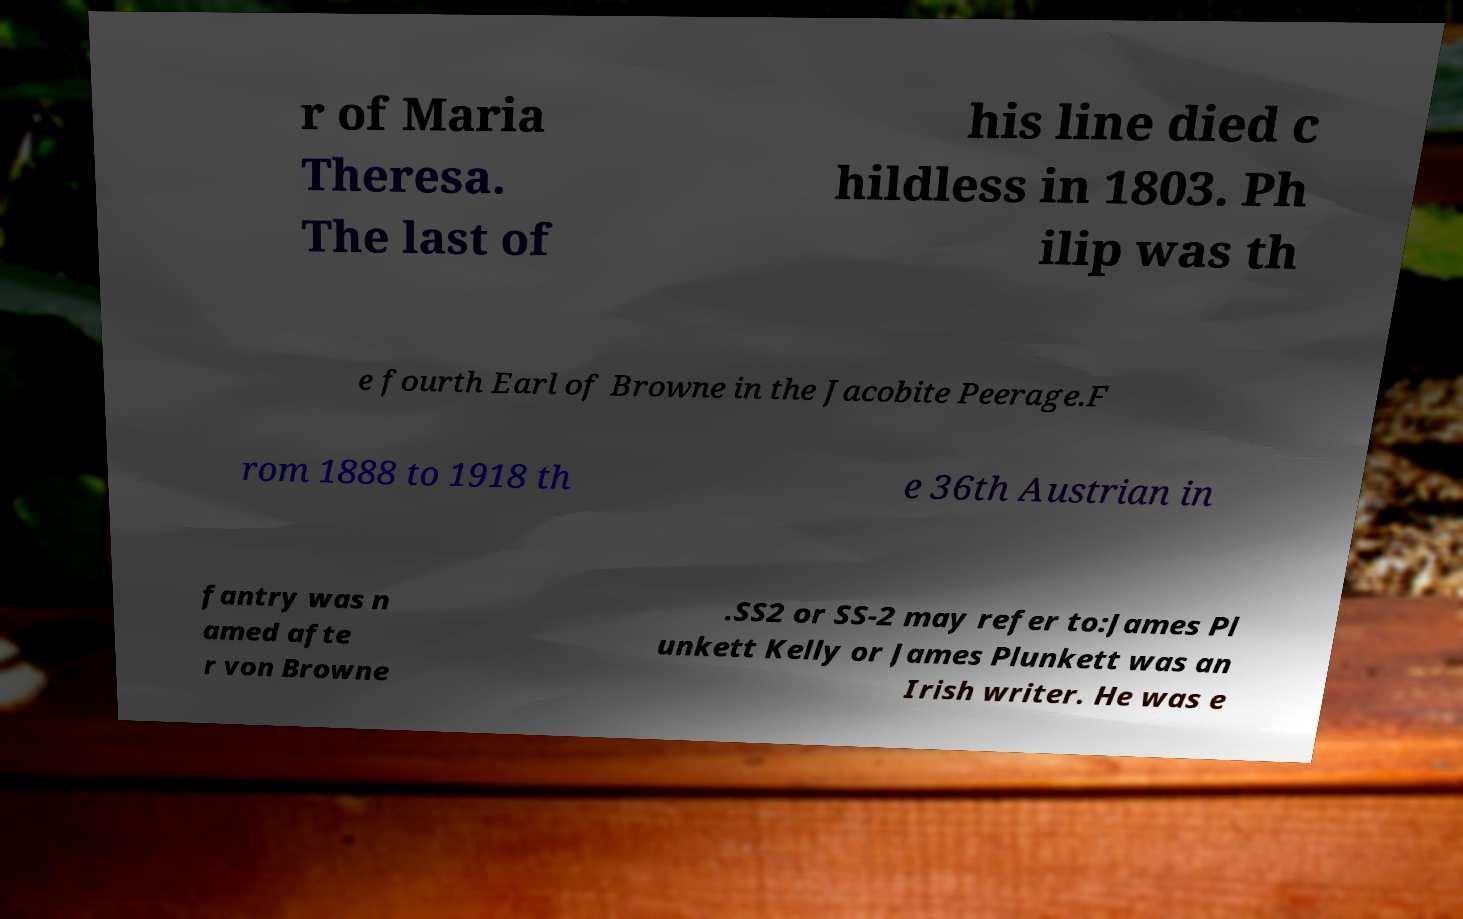There's text embedded in this image that I need extracted. Can you transcribe it verbatim? r of Maria Theresa. The last of his line died c hildless in 1803. Ph ilip was th e fourth Earl of Browne in the Jacobite Peerage.F rom 1888 to 1918 th e 36th Austrian in fantry was n amed afte r von Browne .SS2 or SS-2 may refer to:James Pl unkett Kelly or James Plunkett was an Irish writer. He was e 